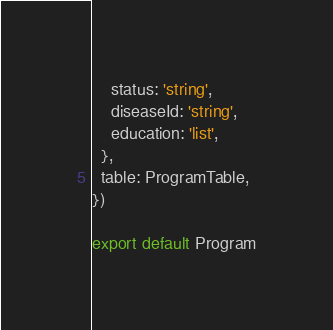<code> <loc_0><loc_0><loc_500><loc_500><_JavaScript_>    status: 'string',
    diseaseId: 'string',
    education: 'list',
  },
  table: ProgramTable,
})

export default Program
</code> 